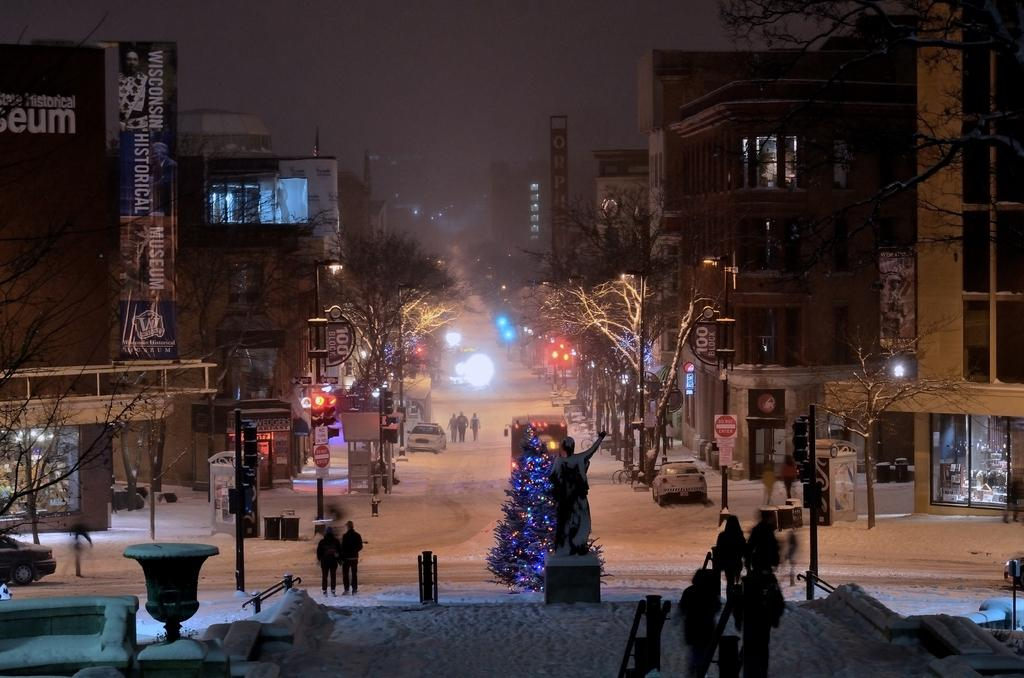What type of structures can be seen in the image? There are many buildings in the image. What other natural elements are present in the image? There are trees in the image. Are there any living beings visible in the image? Yes, there are people in the image. What mode of transportation can be seen in the image? There is a vehicle in the image. Is there any artwork or decoration present in the image? Yes, there is a sculpture in the image. What is the weather like in the image? There is snow in the image, indicating a cold or wintery setting. Are there any holiday-related items in the image? Yes, there is a Christmas tree in the image. What type of signage or advertisement is present in the image? There is a poster in the image. What type of vertical structure is present in the image? There is a pole in the image. What type of surface can be seen in the image? There is a road in the image. What can be seen in the sky in the image? There is a sky visible in the image. How many rabbits can be seen hopping on the road in the image? There are no rabbits present in the image. What day of the week is depicted in the image? The image does not depict a specific day of the week. What type of food is being shared among the people in the image? There is no food, including crackers, visible in the image. 